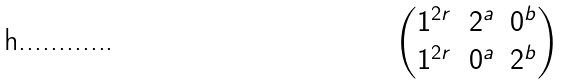Convert formula to latex. <formula><loc_0><loc_0><loc_500><loc_500>\begin{pmatrix} 1 ^ { 2 r } & 2 ^ { a } & 0 ^ { b } \\ 1 ^ { 2 r } & 0 ^ { a } & 2 ^ { b } \end{pmatrix}</formula> 